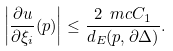<formula> <loc_0><loc_0><loc_500><loc_500>\left | \frac { \partial u } { \partial \xi _ { i } } ( p ) \right | \leq \frac { 2 \ m c C _ { 1 } } { d _ { E } ( p , \partial \Delta ) } .</formula> 